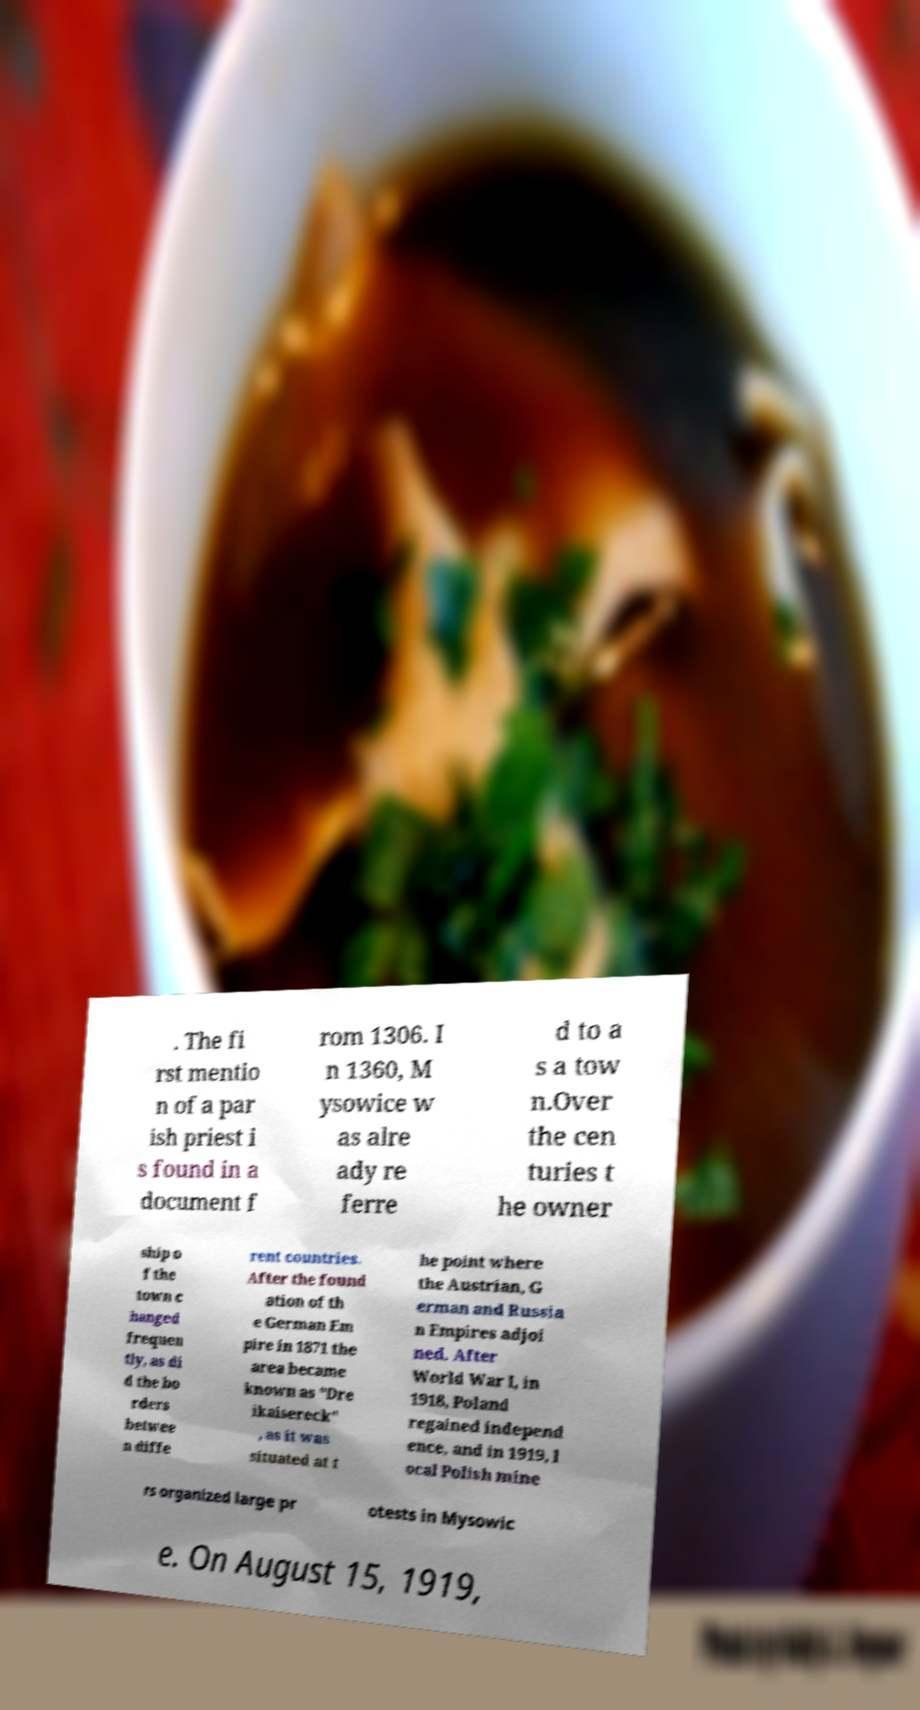Please identify and transcribe the text found in this image. . The fi rst mentio n of a par ish priest i s found in a document f rom 1306. I n 1360, M ysowice w as alre ady re ferre d to a s a tow n.Over the cen turies t he owner ship o f the town c hanged frequen tly, as di d the bo rders betwee n diffe rent countries. After the found ation of th e German Em pire in 1871 the area became known as "Dre ikaisereck" , as it was situated at t he point where the Austrian, G erman and Russia n Empires adjoi ned. After World War I, in 1918, Poland regained independ ence, and in 1919, l ocal Polish mine rs organized large pr otests in Mysowic e. On August 15, 1919, 